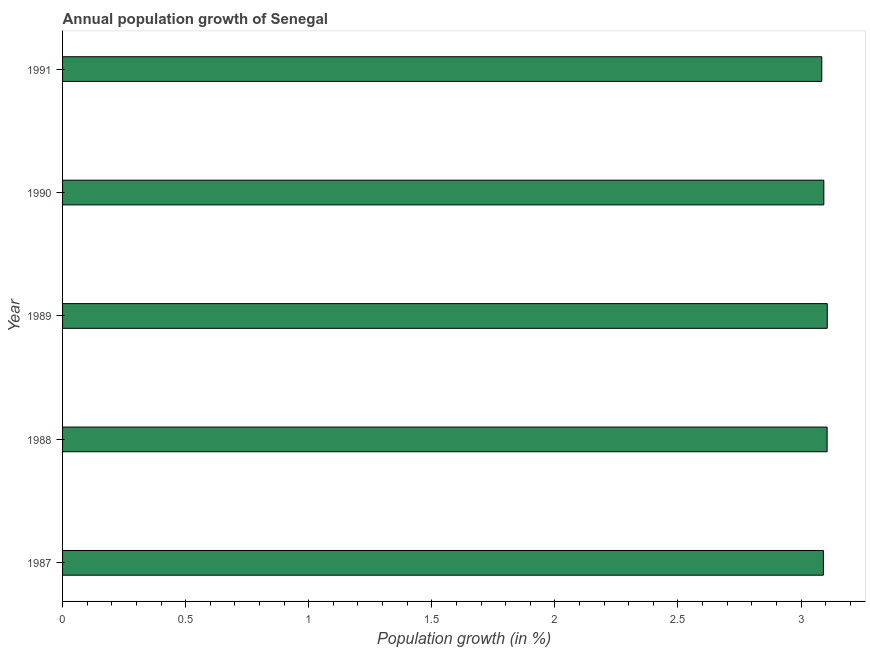Does the graph contain any zero values?
Your response must be concise. No. Does the graph contain grids?
Keep it short and to the point. No. What is the title of the graph?
Your response must be concise. Annual population growth of Senegal. What is the label or title of the X-axis?
Make the answer very short. Population growth (in %). What is the population growth in 1990?
Keep it short and to the point. 3.09. Across all years, what is the maximum population growth?
Ensure brevity in your answer.  3.11. Across all years, what is the minimum population growth?
Your answer should be very brief. 3.08. What is the sum of the population growth?
Provide a succinct answer. 15.48. What is the difference between the population growth in 1987 and 1989?
Keep it short and to the point. -0.02. What is the average population growth per year?
Your response must be concise. 3.1. What is the median population growth?
Your answer should be compact. 3.09. Is the population growth in 1988 less than that in 1990?
Offer a terse response. No. Is the difference between the population growth in 1987 and 1988 greater than the difference between any two years?
Offer a terse response. No. Is the sum of the population growth in 1987 and 1990 greater than the maximum population growth across all years?
Give a very brief answer. Yes. What is the difference between the highest and the lowest population growth?
Offer a terse response. 0.02. How many bars are there?
Keep it short and to the point. 5. How many years are there in the graph?
Offer a terse response. 5. Are the values on the major ticks of X-axis written in scientific E-notation?
Your response must be concise. No. What is the Population growth (in %) in 1987?
Keep it short and to the point. 3.09. What is the Population growth (in %) of 1988?
Make the answer very short. 3.11. What is the Population growth (in %) of 1989?
Offer a terse response. 3.11. What is the Population growth (in %) of 1990?
Ensure brevity in your answer.  3.09. What is the Population growth (in %) of 1991?
Make the answer very short. 3.08. What is the difference between the Population growth (in %) in 1987 and 1988?
Your answer should be compact. -0.02. What is the difference between the Population growth (in %) in 1987 and 1989?
Provide a succinct answer. -0.02. What is the difference between the Population growth (in %) in 1987 and 1990?
Make the answer very short. -0. What is the difference between the Population growth (in %) in 1987 and 1991?
Ensure brevity in your answer.  0.01. What is the difference between the Population growth (in %) in 1988 and 1989?
Offer a terse response. -0. What is the difference between the Population growth (in %) in 1988 and 1990?
Ensure brevity in your answer.  0.01. What is the difference between the Population growth (in %) in 1988 and 1991?
Your answer should be compact. 0.02. What is the difference between the Population growth (in %) in 1989 and 1990?
Your response must be concise. 0.01. What is the difference between the Population growth (in %) in 1989 and 1991?
Offer a very short reply. 0.02. What is the difference between the Population growth (in %) in 1990 and 1991?
Your answer should be compact. 0.01. What is the ratio of the Population growth (in %) in 1987 to that in 1988?
Your response must be concise. 0.99. What is the ratio of the Population growth (in %) in 1987 to that in 1989?
Keep it short and to the point. 0.99. What is the ratio of the Population growth (in %) in 1987 to that in 1990?
Give a very brief answer. 1. What is the ratio of the Population growth (in %) in 1987 to that in 1991?
Provide a short and direct response. 1. What is the ratio of the Population growth (in %) in 1988 to that in 1989?
Provide a succinct answer. 1. What is the ratio of the Population growth (in %) in 1989 to that in 1990?
Offer a very short reply. 1. 